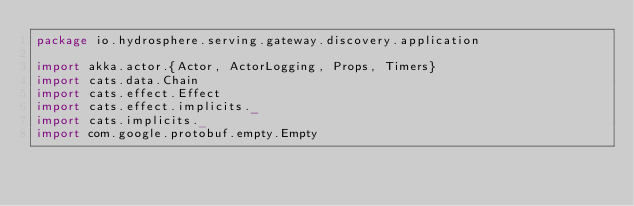Convert code to text. <code><loc_0><loc_0><loc_500><loc_500><_Scala_>package io.hydrosphere.serving.gateway.discovery.application

import akka.actor.{Actor, ActorLogging, Props, Timers}
import cats.data.Chain
import cats.effect.Effect
import cats.effect.implicits._
import cats.implicits._
import com.google.protobuf.empty.Empty</code> 